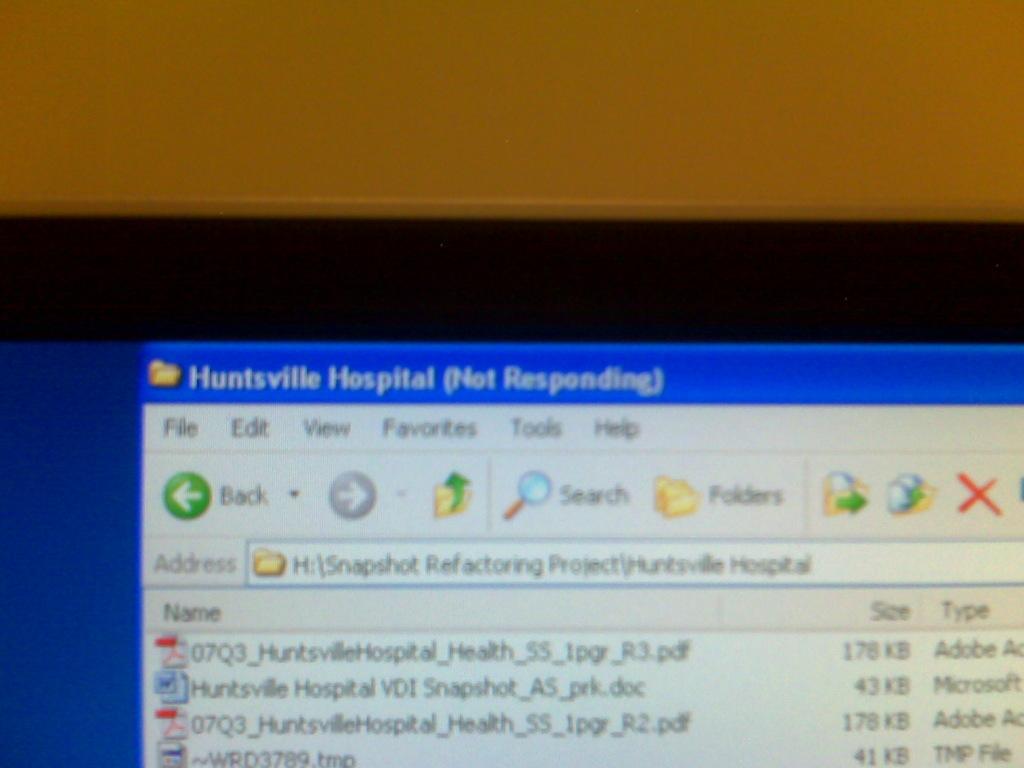What medical facility do these files refer to?
Your response must be concise. Huntsville hospital. What is the size of the first file?
Offer a very short reply. 178 kb. 